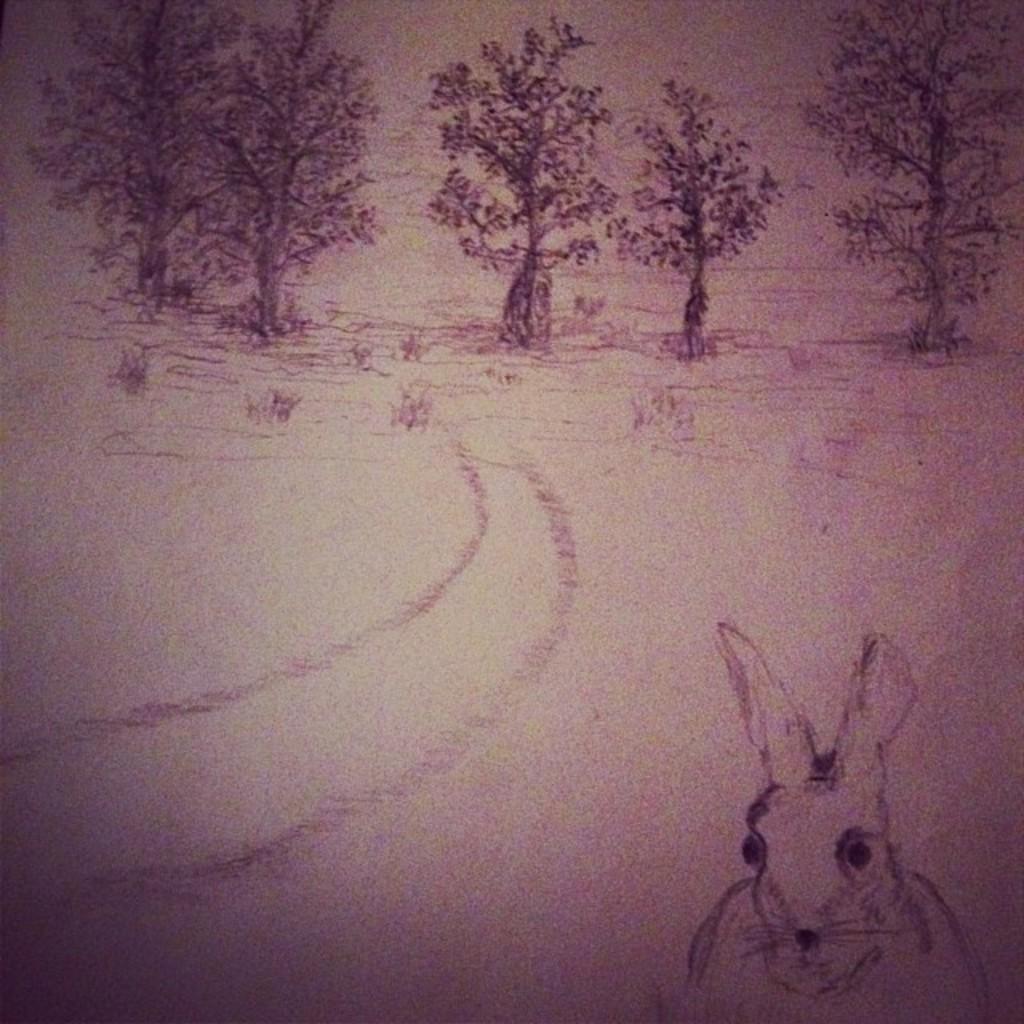How would you summarize this image in a sentence or two? In this image there is an art of a tree and rabbit. 